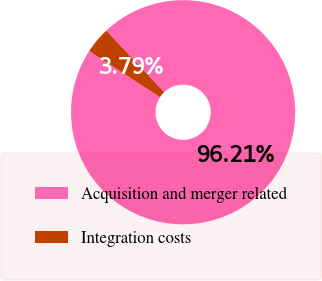<chart> <loc_0><loc_0><loc_500><loc_500><pie_chart><fcel>Acquisition and merger related<fcel>Integration costs<nl><fcel>96.21%<fcel>3.79%<nl></chart> 